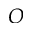Convert formula to latex. <formula><loc_0><loc_0><loc_500><loc_500>O</formula> 